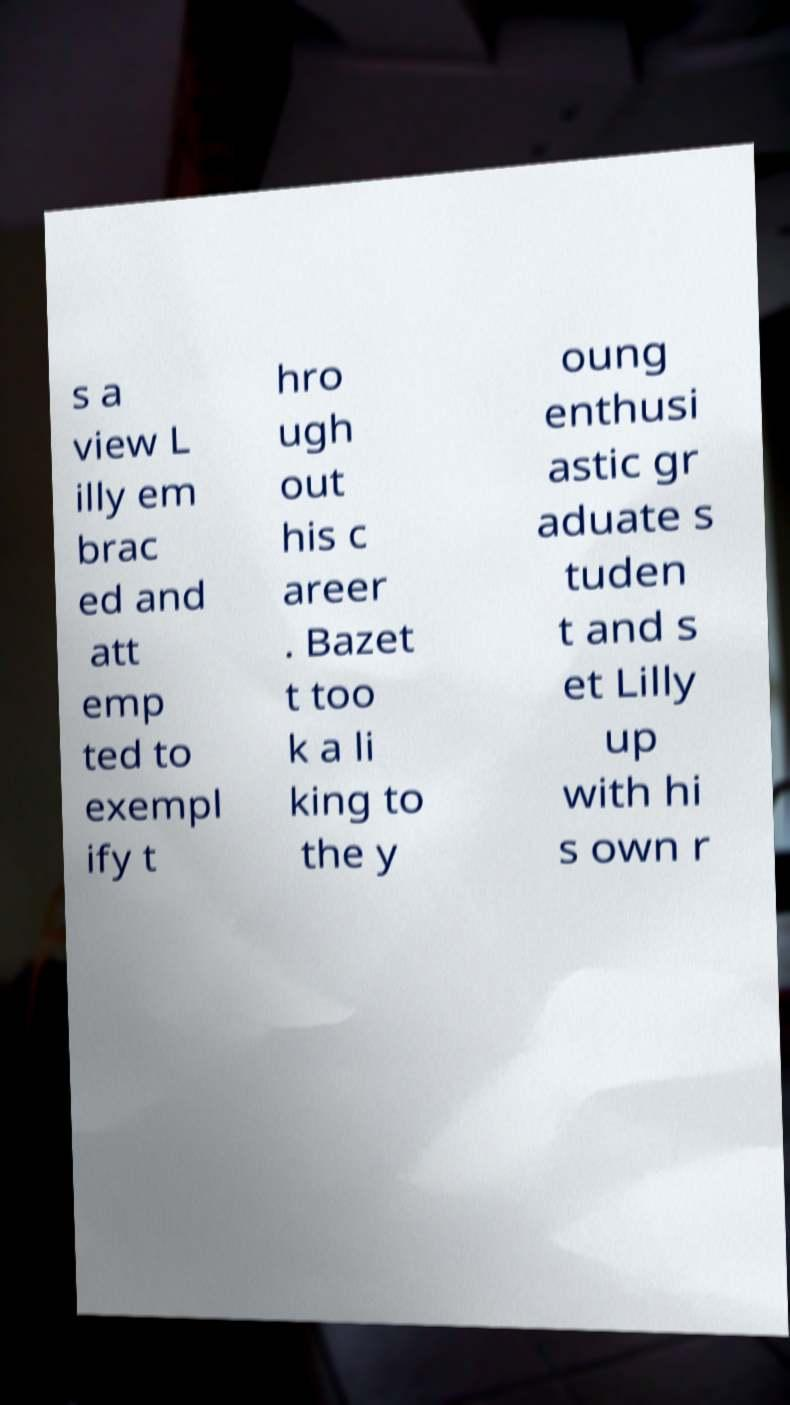Please read and relay the text visible in this image. What does it say? s a view L illy em brac ed and att emp ted to exempl ify t hro ugh out his c areer . Bazet t too k a li king to the y oung enthusi astic gr aduate s tuden t and s et Lilly up with hi s own r 